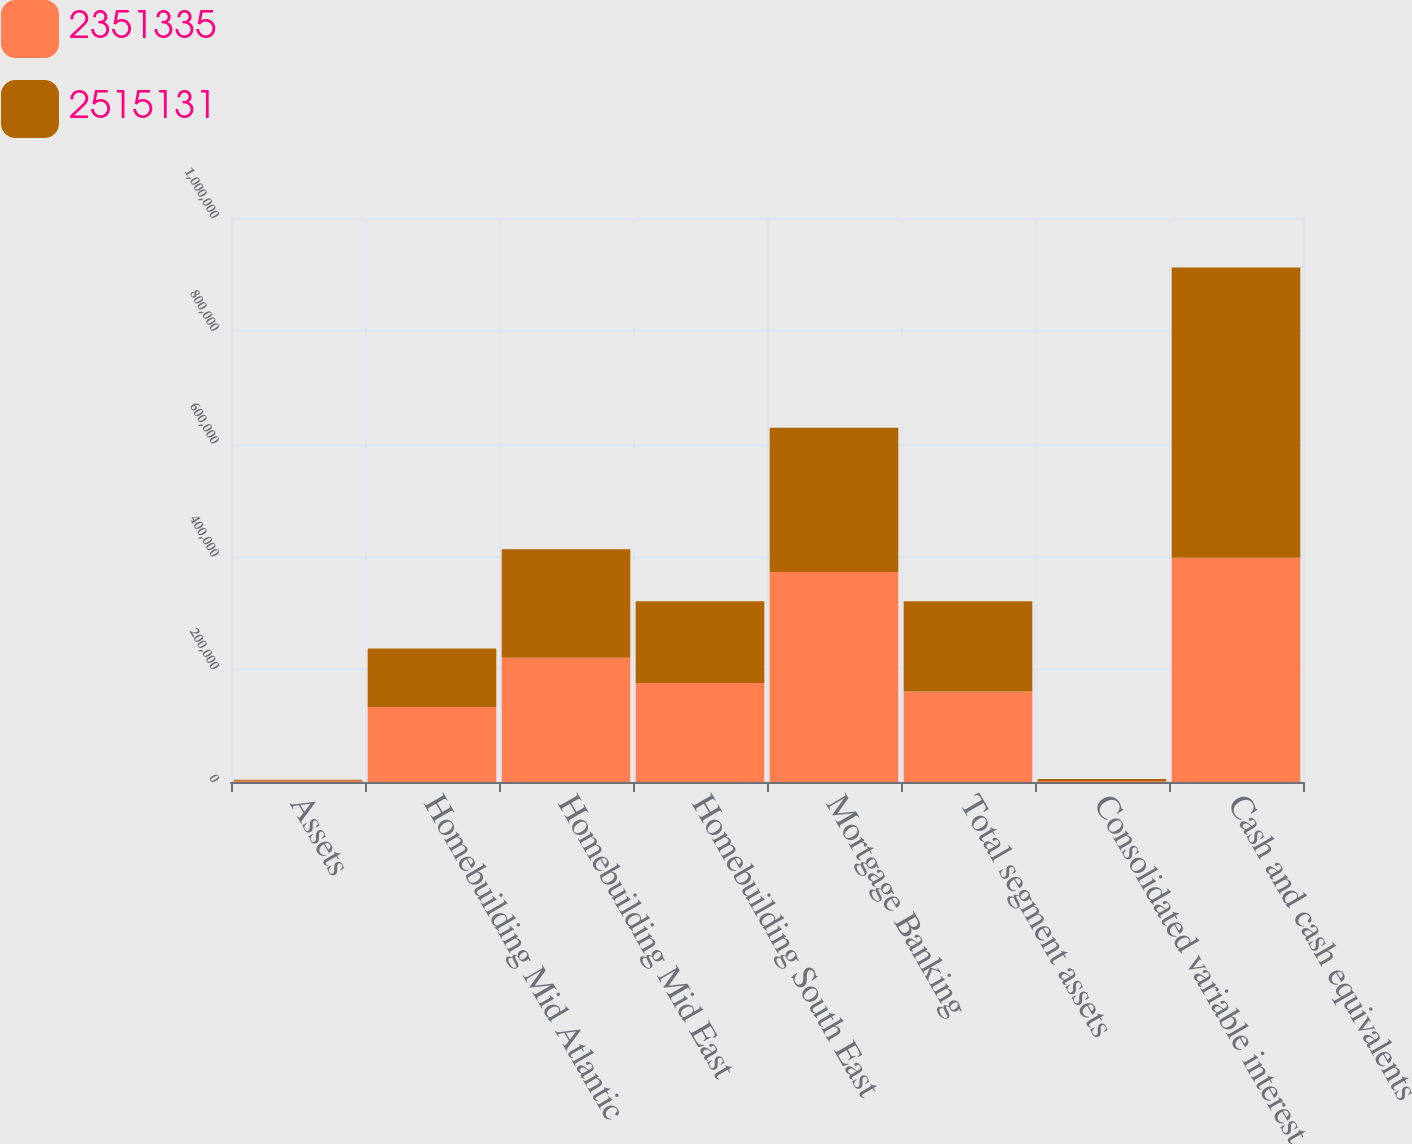Convert chart. <chart><loc_0><loc_0><loc_500><loc_500><stacked_bar_chart><ecel><fcel>Assets<fcel>Homebuilding Mid Atlantic<fcel>Homebuilding Mid East<fcel>Homebuilding South East<fcel>Mortgage Banking<fcel>Total segment assets<fcel>Consolidated variable interest<fcel>Cash and cash equivalents<nl><fcel>2.35134e+06<fcel>2015<fcel>133106<fcel>220094<fcel>175572<fcel>372203<fcel>160256<fcel>1749<fcel>397522<nl><fcel>2.51513e+06<fcel>2014<fcel>103631<fcel>192781<fcel>144939<fcel>255969<fcel>160256<fcel>3590<fcel>514780<nl></chart> 